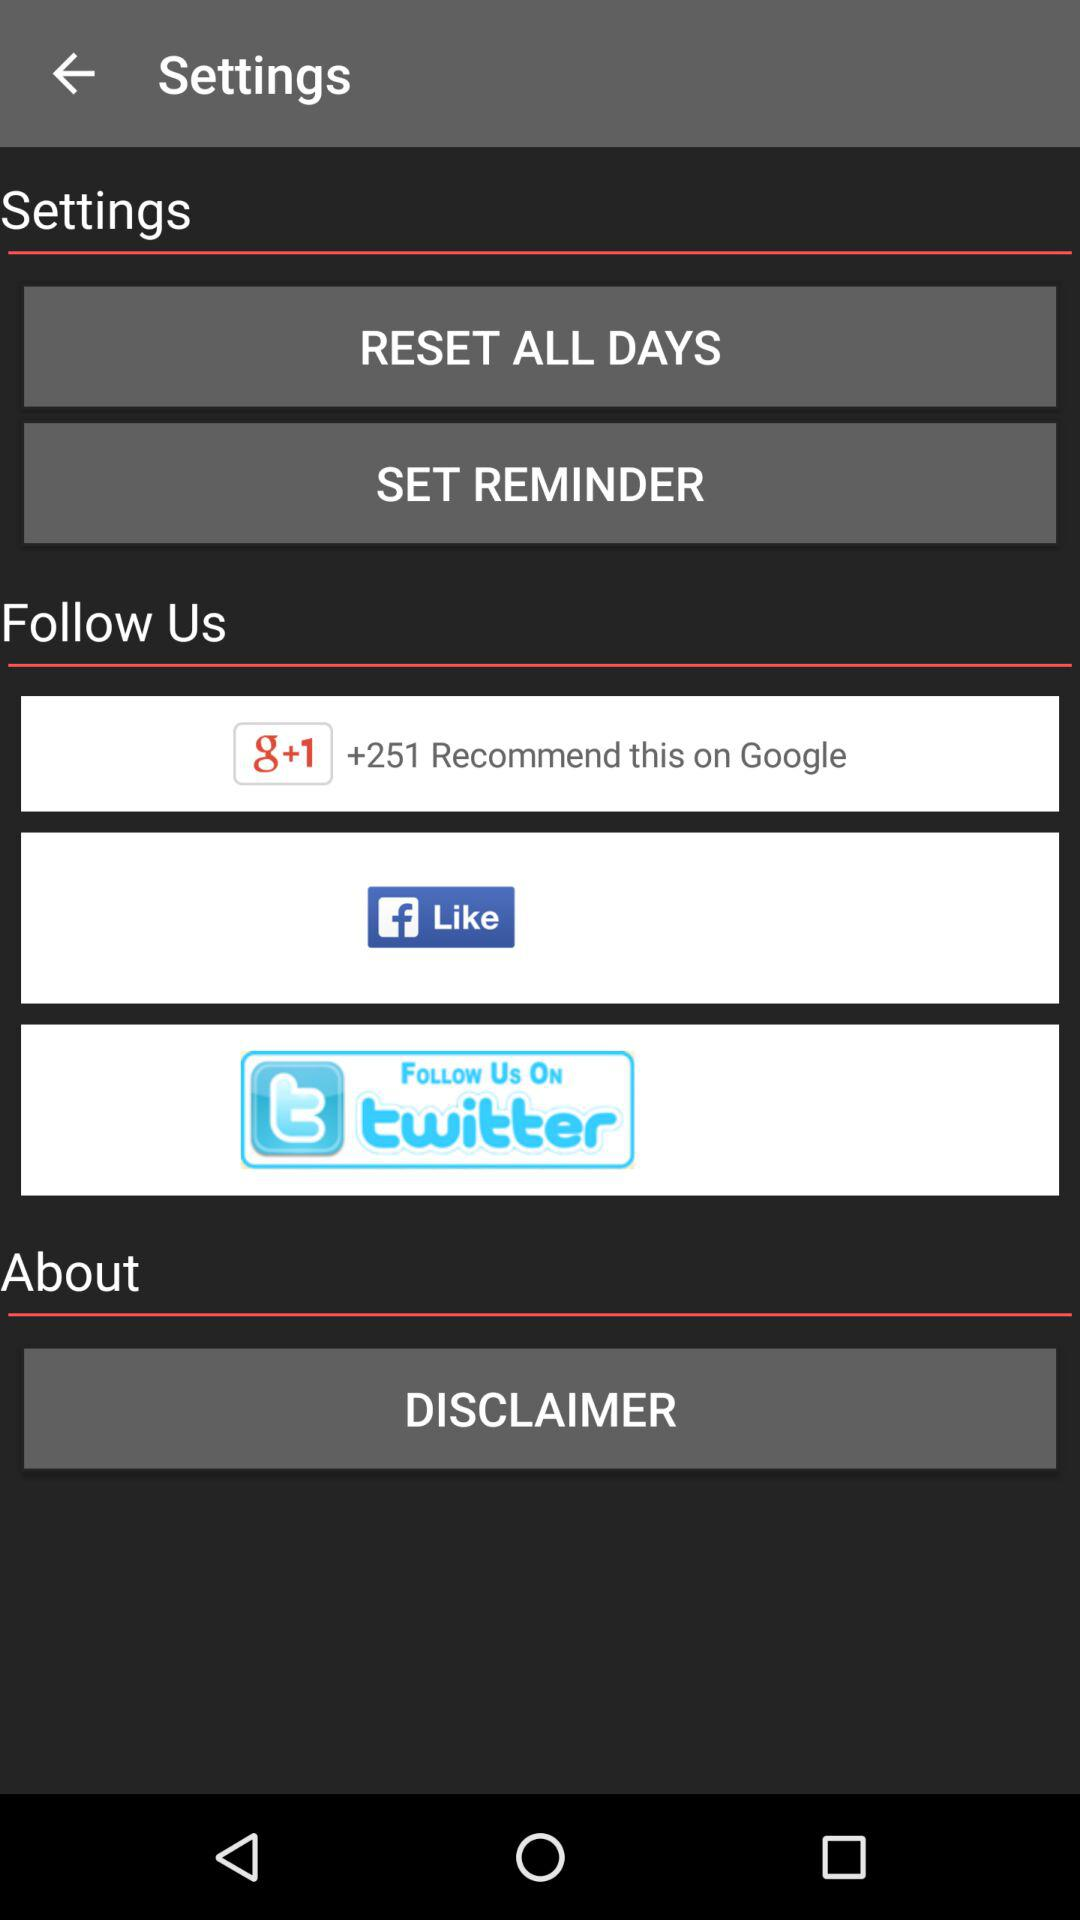How many users recommended the application on Google? There are 251 users who recommended the application on Google. 